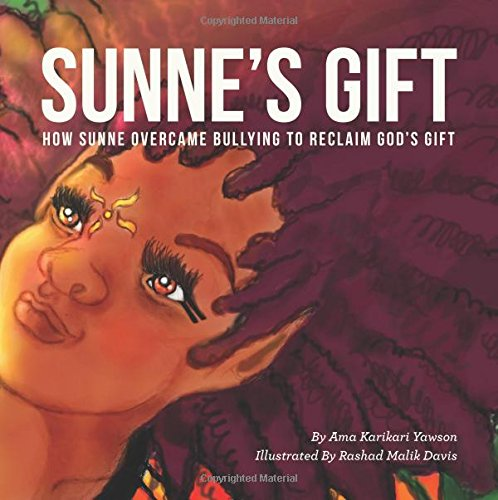What is the genre of this book? This book falls under the genre of Children's Books, specifically targeting young readers with themes of empowerment and overcoming challenges. 